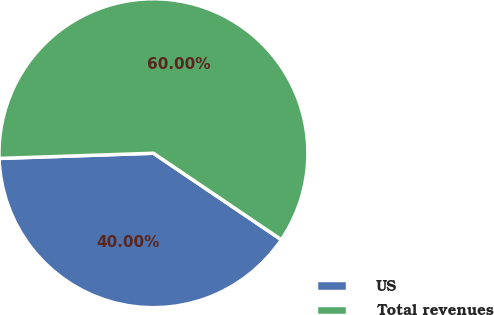Convert chart. <chart><loc_0><loc_0><loc_500><loc_500><pie_chart><fcel>US<fcel>Total revenues<nl><fcel>40.0%<fcel>60.0%<nl></chart> 